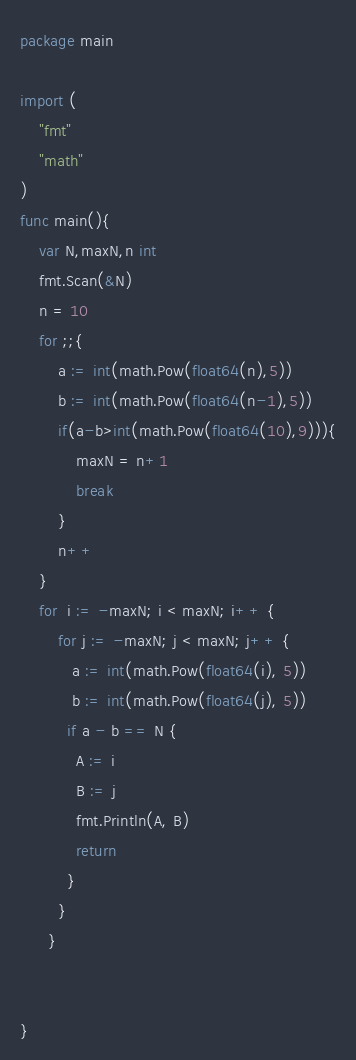Convert code to text. <code><loc_0><loc_0><loc_500><loc_500><_Go_>package main

import (
	"fmt"
	"math"
)
func main(){
	var N,maxN,n int
	fmt.Scan(&N)
	n = 10
	for ;;{
		a := int(math.Pow(float64(n),5))
		b := int(math.Pow(float64(n-1),5))
		if(a-b>int(math.Pow(float64(10),9))){
			maxN = n+1
			break
		}
		n++
	}
	for  i := -maxN; i < maxN; i++ {
		for j := -maxN; j < maxN; j++ {
		   a := int(math.Pow(float64(i), 5))
		   b := int(math.Pow(float64(j), 5))
		  if a - b == N {
			A := i
			B := j
			fmt.Println(A, B)
			return
		  }
		}
	  }


}</code> 